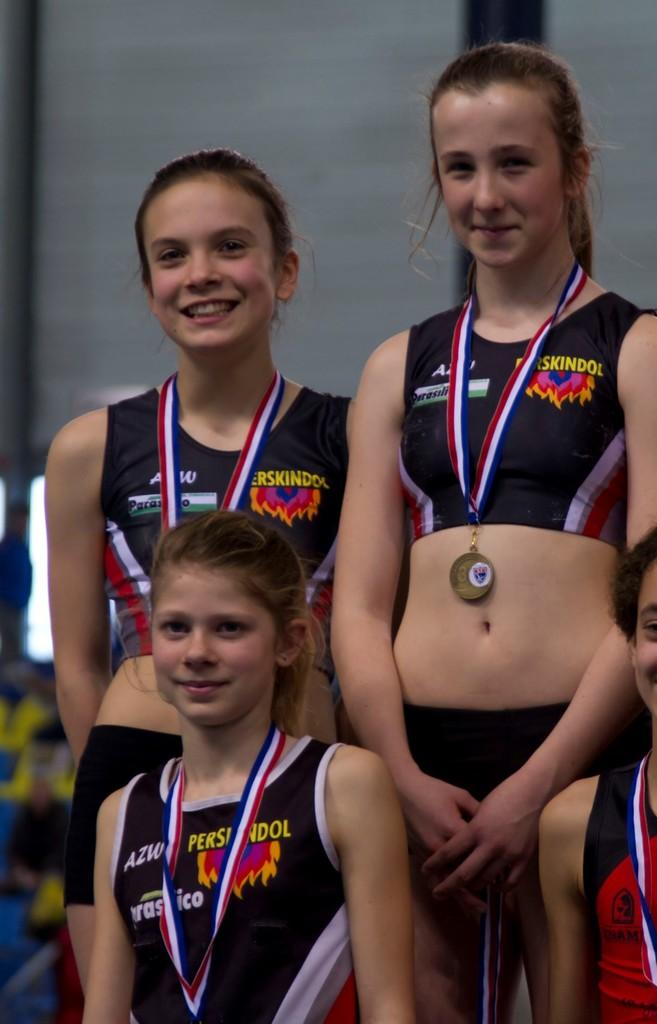<image>
Render a clear and concise summary of the photo. Four girls wearing Perskindol uniforms are displaying medals 